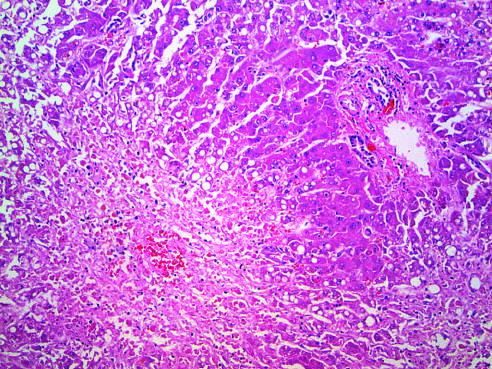s residual normal tissue indicated by the asterisk?
Answer the question using a single word or phrase. Yes 